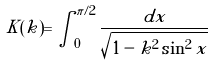Convert formula to latex. <formula><loc_0><loc_0><loc_500><loc_500>K ( k ) = \int _ { 0 } ^ { \pi / 2 } \frac { d x } { \sqrt { 1 - k ^ { 2 } \sin ^ { 2 } x } }</formula> 